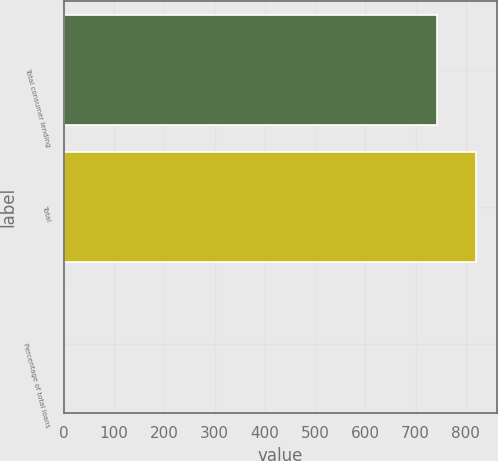Convert chart. <chart><loc_0><loc_0><loc_500><loc_500><bar_chart><fcel>Total consumer lending<fcel>Total<fcel>Percentage of total loans<nl><fcel>743<fcel>821.16<fcel>0.37<nl></chart> 